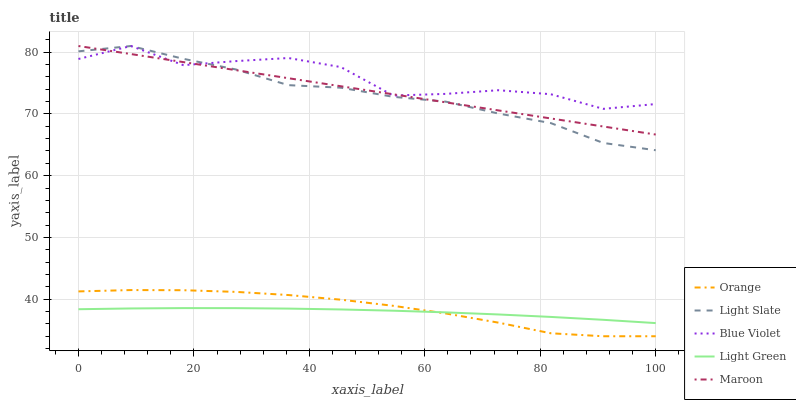Does Light Slate have the minimum area under the curve?
Answer yes or no. No. Does Light Slate have the maximum area under the curve?
Answer yes or no. No. Is Light Slate the smoothest?
Answer yes or no. No. Is Light Slate the roughest?
Answer yes or no. No. Does Light Slate have the lowest value?
Answer yes or no. No. Does Light Green have the highest value?
Answer yes or no. No. Is Light Green less than Light Slate?
Answer yes or no. Yes. Is Light Slate greater than Light Green?
Answer yes or no. Yes. Does Light Green intersect Light Slate?
Answer yes or no. No. 